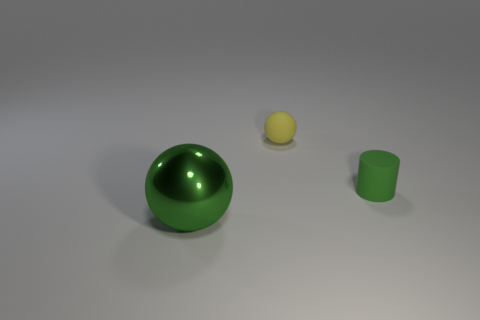Add 2 yellow objects. How many objects exist? 5 Subtract all cylinders. How many objects are left? 2 Add 2 large purple metallic things. How many large purple metallic things exist? 2 Subtract 1 green cylinders. How many objects are left? 2 Subtract all small green matte cylinders. Subtract all tiny spheres. How many objects are left? 1 Add 1 green metallic balls. How many green metallic balls are left? 2 